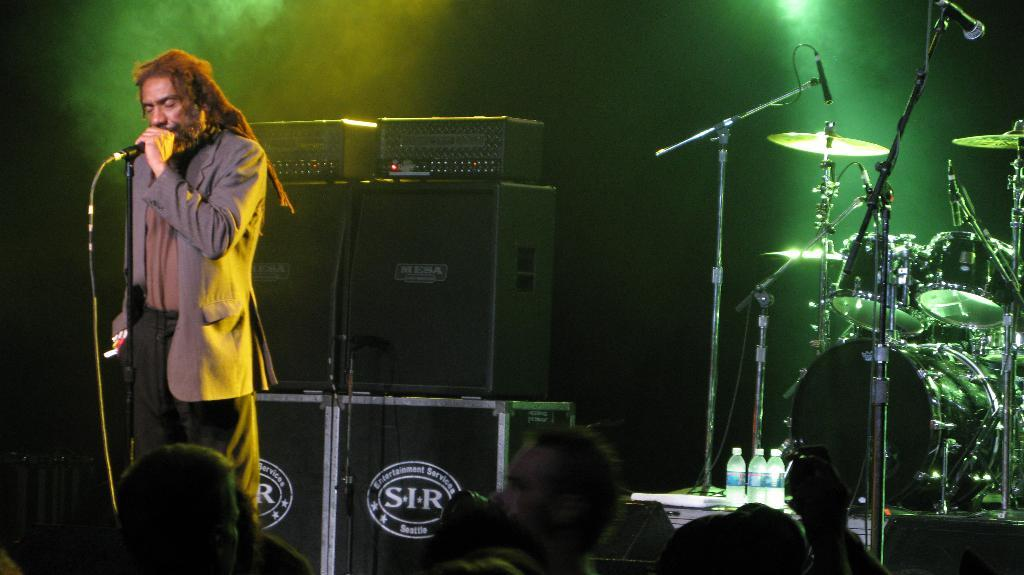What is the man in the image doing? The man is standing in the image and holding a microphone in his hand. What can be seen in the background of the image? There are musical drums in the background of the image. How many people are present in the image? There is a group of people standing in the image. What type of pot is the doctor using to treat the men in the image? There is no doctor or pot present in the image. The man is holding a microphone, and there are musical drums in the background. 